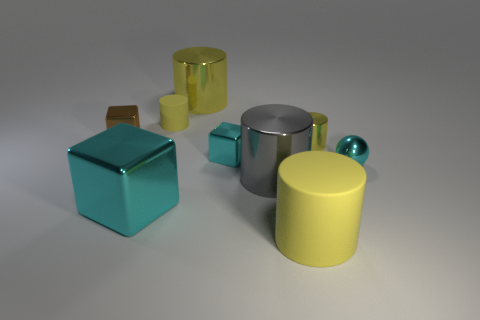How many yellow cylinders must be subtracted to get 2 yellow cylinders? 2 Subtract all small cylinders. How many cylinders are left? 3 Add 1 big yellow rubber objects. How many objects exist? 10 Subtract all brown cubes. How many cubes are left? 2 Subtract 0 purple cylinders. How many objects are left? 9 Subtract all blocks. How many objects are left? 6 Subtract 3 cubes. How many cubes are left? 0 Subtract all yellow cubes. Subtract all brown spheres. How many cubes are left? 3 Subtract all green blocks. How many yellow cylinders are left? 4 Subtract all tiny brown objects. Subtract all big yellow rubber cylinders. How many objects are left? 7 